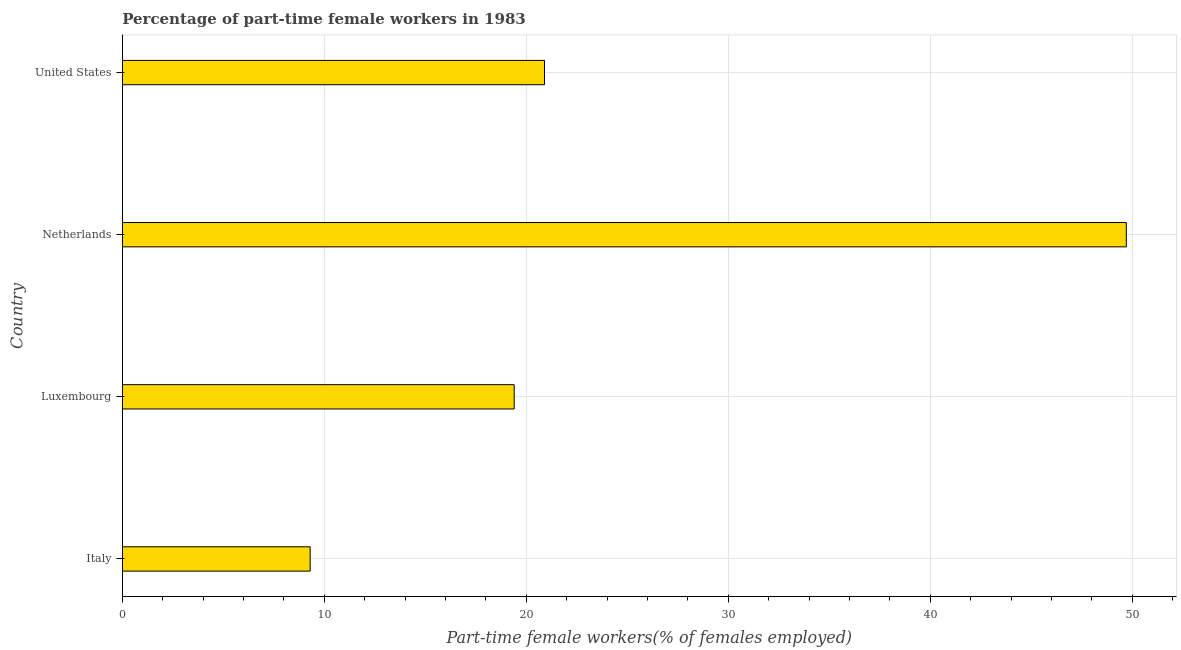Does the graph contain grids?
Provide a succinct answer. Yes. What is the title of the graph?
Make the answer very short. Percentage of part-time female workers in 1983. What is the label or title of the X-axis?
Ensure brevity in your answer.  Part-time female workers(% of females employed). What is the label or title of the Y-axis?
Your response must be concise. Country. What is the percentage of part-time female workers in Netherlands?
Provide a short and direct response. 49.7. Across all countries, what is the maximum percentage of part-time female workers?
Keep it short and to the point. 49.7. Across all countries, what is the minimum percentage of part-time female workers?
Your answer should be very brief. 9.3. In which country was the percentage of part-time female workers maximum?
Provide a succinct answer. Netherlands. In which country was the percentage of part-time female workers minimum?
Keep it short and to the point. Italy. What is the sum of the percentage of part-time female workers?
Your response must be concise. 99.3. What is the difference between the percentage of part-time female workers in Netherlands and United States?
Offer a very short reply. 28.8. What is the average percentage of part-time female workers per country?
Offer a terse response. 24.82. What is the median percentage of part-time female workers?
Your response must be concise. 20.15. In how many countries, is the percentage of part-time female workers greater than 50 %?
Your answer should be very brief. 0. What is the ratio of the percentage of part-time female workers in Luxembourg to that in United States?
Make the answer very short. 0.93. Is the percentage of part-time female workers in Italy less than that in United States?
Provide a short and direct response. Yes. Is the difference between the percentage of part-time female workers in Italy and United States greater than the difference between any two countries?
Make the answer very short. No. What is the difference between the highest and the second highest percentage of part-time female workers?
Provide a short and direct response. 28.8. What is the difference between the highest and the lowest percentage of part-time female workers?
Provide a succinct answer. 40.4. How many bars are there?
Offer a very short reply. 4. Are all the bars in the graph horizontal?
Keep it short and to the point. Yes. How many countries are there in the graph?
Give a very brief answer. 4. Are the values on the major ticks of X-axis written in scientific E-notation?
Make the answer very short. No. What is the Part-time female workers(% of females employed) in Italy?
Provide a succinct answer. 9.3. What is the Part-time female workers(% of females employed) in Luxembourg?
Provide a succinct answer. 19.4. What is the Part-time female workers(% of females employed) of Netherlands?
Offer a very short reply. 49.7. What is the Part-time female workers(% of females employed) in United States?
Offer a terse response. 20.9. What is the difference between the Part-time female workers(% of females employed) in Italy and Netherlands?
Offer a terse response. -40.4. What is the difference between the Part-time female workers(% of females employed) in Italy and United States?
Make the answer very short. -11.6. What is the difference between the Part-time female workers(% of females employed) in Luxembourg and Netherlands?
Ensure brevity in your answer.  -30.3. What is the difference between the Part-time female workers(% of females employed) in Luxembourg and United States?
Keep it short and to the point. -1.5. What is the difference between the Part-time female workers(% of females employed) in Netherlands and United States?
Your answer should be compact. 28.8. What is the ratio of the Part-time female workers(% of females employed) in Italy to that in Luxembourg?
Provide a short and direct response. 0.48. What is the ratio of the Part-time female workers(% of females employed) in Italy to that in Netherlands?
Your answer should be compact. 0.19. What is the ratio of the Part-time female workers(% of females employed) in Italy to that in United States?
Provide a short and direct response. 0.45. What is the ratio of the Part-time female workers(% of females employed) in Luxembourg to that in Netherlands?
Offer a very short reply. 0.39. What is the ratio of the Part-time female workers(% of females employed) in Luxembourg to that in United States?
Make the answer very short. 0.93. What is the ratio of the Part-time female workers(% of females employed) in Netherlands to that in United States?
Your answer should be compact. 2.38. 